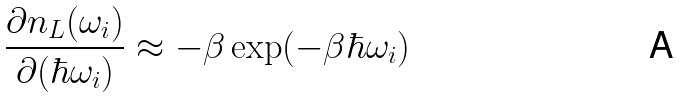Convert formula to latex. <formula><loc_0><loc_0><loc_500><loc_500>\frac { \partial n _ { L } ( \omega _ { i } ) } { \partial ( \hbar { \omega } _ { i } ) } \approx - \beta \exp ( - \beta \hbar { \omega } _ { i } )</formula> 